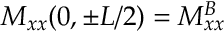<formula> <loc_0><loc_0><loc_500><loc_500>M _ { x x } ( 0 , \pm L / 2 ) = M _ { x x } ^ { B }</formula> 